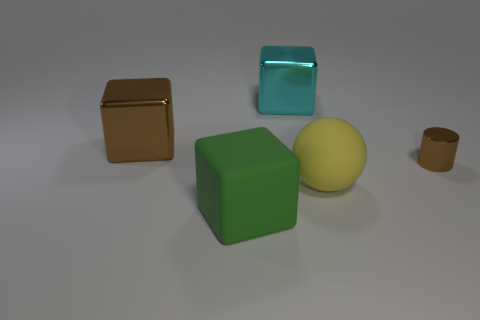Is there anything else that is the same shape as the big yellow rubber thing?
Your response must be concise. No. There is a big yellow rubber object; are there any big yellow matte objects to the right of it?
Provide a short and direct response. No. Are there any other things that are the same size as the cylinder?
Your answer should be compact. No. There is a big cube that is made of the same material as the big yellow ball; what is its color?
Your answer should be very brief. Green. Do the shiny thing that is right of the big yellow matte thing and the large cube that is left of the green matte thing have the same color?
Your answer should be compact. Yes. How many spheres are small blue rubber objects or large brown objects?
Give a very brief answer. 0. Is the number of yellow matte objects in front of the big matte block the same as the number of large yellow spheres?
Your response must be concise. No. There is a large yellow ball that is in front of the brown object to the left of the metallic thing right of the big matte sphere; what is it made of?
Give a very brief answer. Rubber. There is a big cube that is the same color as the tiny cylinder; what is its material?
Provide a short and direct response. Metal. What number of things are objects that are in front of the small brown object or brown things?
Your answer should be compact. 4. 